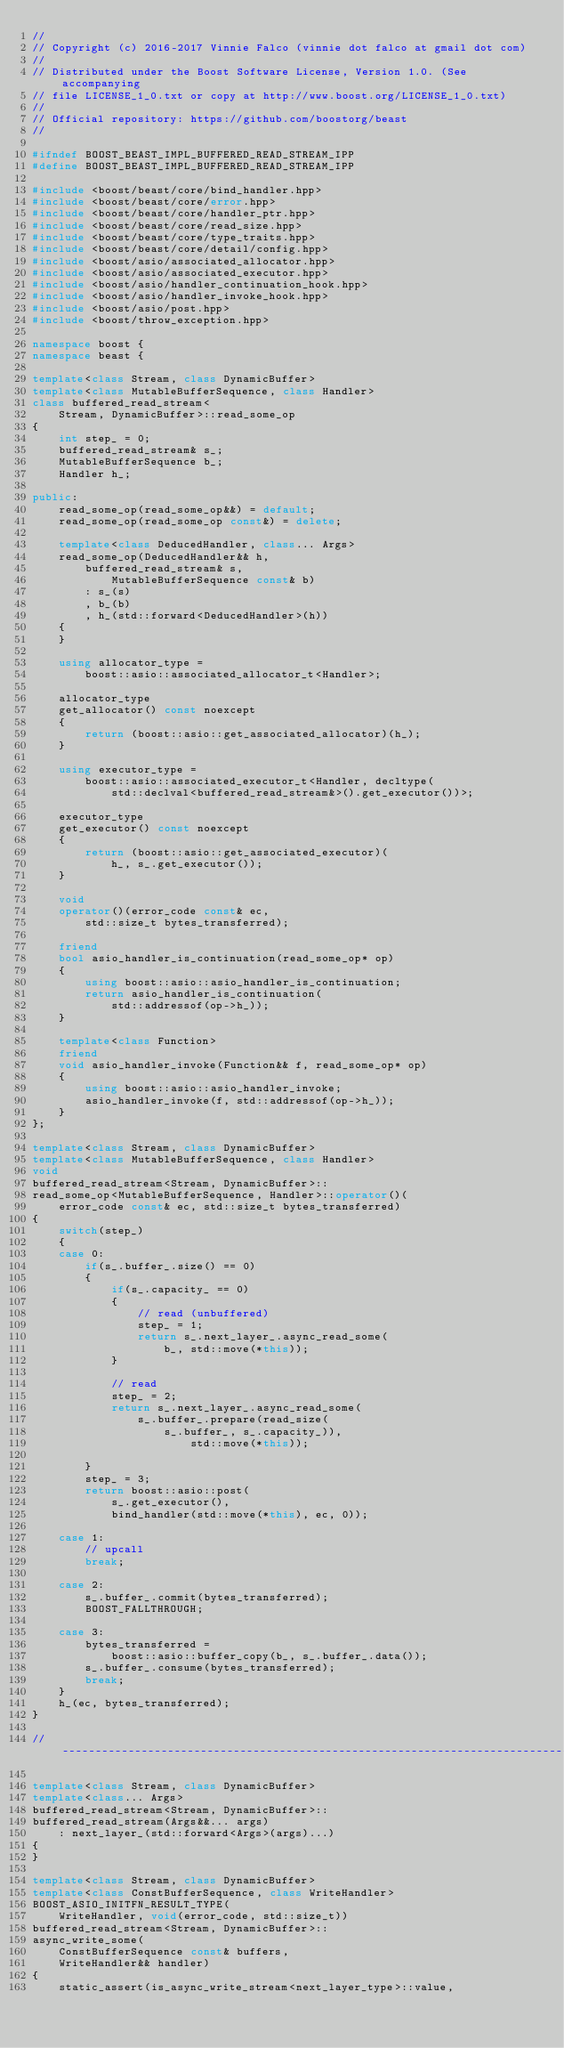Convert code to text. <code><loc_0><loc_0><loc_500><loc_500><_C++_>//
// Copyright (c) 2016-2017 Vinnie Falco (vinnie dot falco at gmail dot com)
//
// Distributed under the Boost Software License, Version 1.0. (See accompanying
// file LICENSE_1_0.txt or copy at http://www.boost.org/LICENSE_1_0.txt)
//
// Official repository: https://github.com/boostorg/beast
//

#ifndef BOOST_BEAST_IMPL_BUFFERED_READ_STREAM_IPP
#define BOOST_BEAST_IMPL_BUFFERED_READ_STREAM_IPP

#include <boost/beast/core/bind_handler.hpp>
#include <boost/beast/core/error.hpp>
#include <boost/beast/core/handler_ptr.hpp>
#include <boost/beast/core/read_size.hpp>
#include <boost/beast/core/type_traits.hpp>
#include <boost/beast/core/detail/config.hpp>
#include <boost/asio/associated_allocator.hpp>
#include <boost/asio/associated_executor.hpp>
#include <boost/asio/handler_continuation_hook.hpp>
#include <boost/asio/handler_invoke_hook.hpp>
#include <boost/asio/post.hpp>
#include <boost/throw_exception.hpp>

namespace boost {
namespace beast {

template<class Stream, class DynamicBuffer>
template<class MutableBufferSequence, class Handler>
class buffered_read_stream<
    Stream, DynamicBuffer>::read_some_op
{
    int step_ = 0;
    buffered_read_stream& s_;
    MutableBufferSequence b_;
    Handler h_;

public:
    read_some_op(read_some_op&&) = default;
    read_some_op(read_some_op const&) = delete;

    template<class DeducedHandler, class... Args>
    read_some_op(DeducedHandler&& h,
        buffered_read_stream& s,
            MutableBufferSequence const& b)
        : s_(s)
        , b_(b)
        , h_(std::forward<DeducedHandler>(h))
    {
    }

    using allocator_type =
        boost::asio::associated_allocator_t<Handler>;

    allocator_type
    get_allocator() const noexcept
    {
        return (boost::asio::get_associated_allocator)(h_);
    }

    using executor_type =
        boost::asio::associated_executor_t<Handler, decltype(
            std::declval<buffered_read_stream&>().get_executor())>;

    executor_type
    get_executor() const noexcept
    {
        return (boost::asio::get_associated_executor)(
            h_, s_.get_executor());
    }

    void
    operator()(error_code const& ec,
        std::size_t bytes_transferred);

    friend
    bool asio_handler_is_continuation(read_some_op* op)
    {
        using boost::asio::asio_handler_is_continuation;
        return asio_handler_is_continuation(
            std::addressof(op->h_));
    }

    template<class Function>
    friend
    void asio_handler_invoke(Function&& f, read_some_op* op)
    {
        using boost::asio::asio_handler_invoke;
        asio_handler_invoke(f, std::addressof(op->h_));
    }
};

template<class Stream, class DynamicBuffer>
template<class MutableBufferSequence, class Handler>
void
buffered_read_stream<Stream, DynamicBuffer>::
read_some_op<MutableBufferSequence, Handler>::operator()(
    error_code const& ec, std::size_t bytes_transferred)
{
    switch(step_)
    {
    case 0:
        if(s_.buffer_.size() == 0)
        {
            if(s_.capacity_ == 0)
            {
                // read (unbuffered)
                step_ = 1;
                return s_.next_layer_.async_read_some(
                    b_, std::move(*this));
            }

            // read
            step_ = 2;
            return s_.next_layer_.async_read_some(
                s_.buffer_.prepare(read_size(
                    s_.buffer_, s_.capacity_)),
                        std::move(*this));

        }
        step_ = 3;
        return boost::asio::post(
            s_.get_executor(),
            bind_handler(std::move(*this), ec, 0));

    case 1:
        // upcall
        break;

    case 2:
        s_.buffer_.commit(bytes_transferred);
        BOOST_FALLTHROUGH;

    case 3:
        bytes_transferred =
            boost::asio::buffer_copy(b_, s_.buffer_.data());
        s_.buffer_.consume(bytes_transferred);
        break;
    }
    h_(ec, bytes_transferred);
}

//------------------------------------------------------------------------------

template<class Stream, class DynamicBuffer>
template<class... Args>
buffered_read_stream<Stream, DynamicBuffer>::
buffered_read_stream(Args&&... args)
    : next_layer_(std::forward<Args>(args)...)
{
}

template<class Stream, class DynamicBuffer>
template<class ConstBufferSequence, class WriteHandler>
BOOST_ASIO_INITFN_RESULT_TYPE(
    WriteHandler, void(error_code, std::size_t))
buffered_read_stream<Stream, DynamicBuffer>::
async_write_some(
    ConstBufferSequence const& buffers,
    WriteHandler&& handler)
{
    static_assert(is_async_write_stream<next_layer_type>::value,</code> 